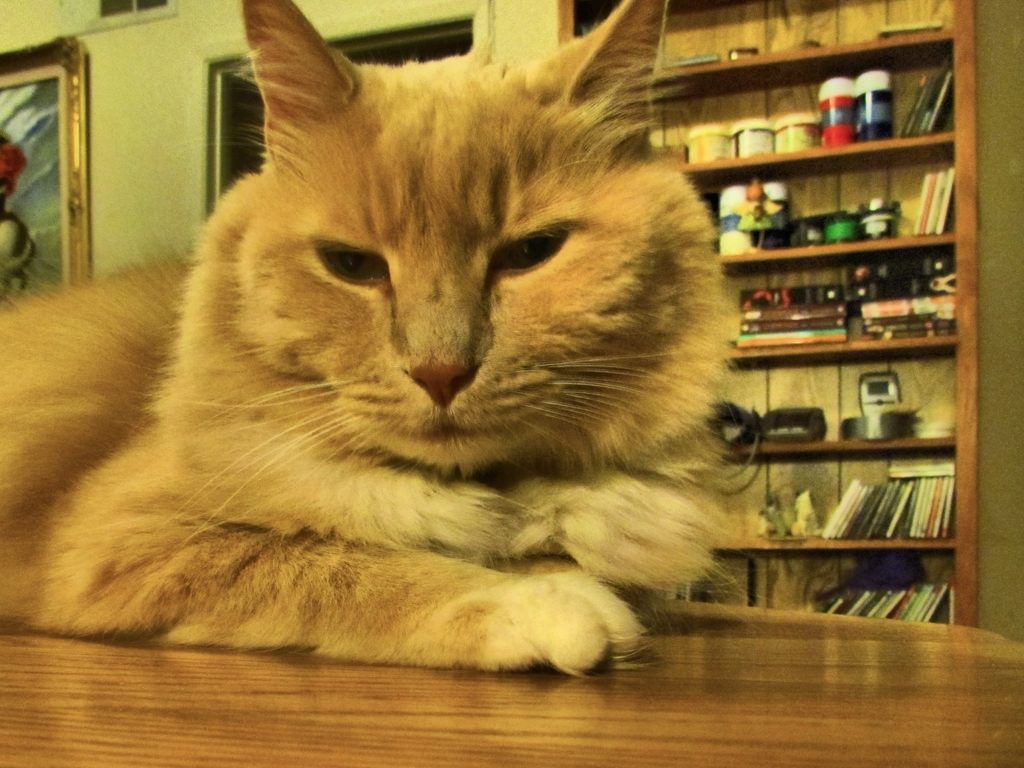How does the surrounding environment reflect on the cat's lifestyle? The cat is indoors, surrounded by books and household items, indicating a comfortable home environment likely with a caring owner. Such a setting often points to a safe and nurturing lifestyle for a domestic cat. 